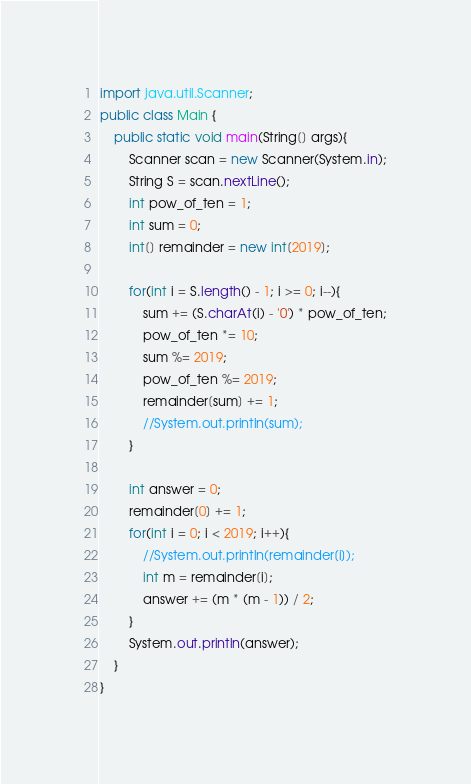<code> <loc_0><loc_0><loc_500><loc_500><_Java_>import java.util.Scanner;
public class Main {
	public static void main(String[] args){
		Scanner scan = new Scanner(System.in);
		String S = scan.nextLine();
		int pow_of_ten = 1;
		int sum = 0;
		int[] remainder = new int[2019];

		for(int i = S.length() - 1; i >= 0; i--){
			sum += (S.charAt(i) - '0') * pow_of_ten;
			pow_of_ten *= 10;
			sum %= 2019;
			pow_of_ten %= 2019;
			remainder[sum] += 1;
			//System.out.println(sum);
		}

		int answer = 0;
		remainder[0] += 1;
		for(int i = 0; i < 2019; i++){
			//System.out.println(remainder[i]);
			int m = remainder[i];
			answer += (m * (m - 1)) / 2;
		}
		System.out.println(answer);
	}
}
</code> 